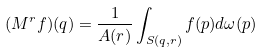<formula> <loc_0><loc_0><loc_500><loc_500>( M ^ { r } f ) ( q ) = \frac { 1 } { A ( r ) } \int _ { S ( q , r ) } f ( p ) d \omega ( p )</formula> 